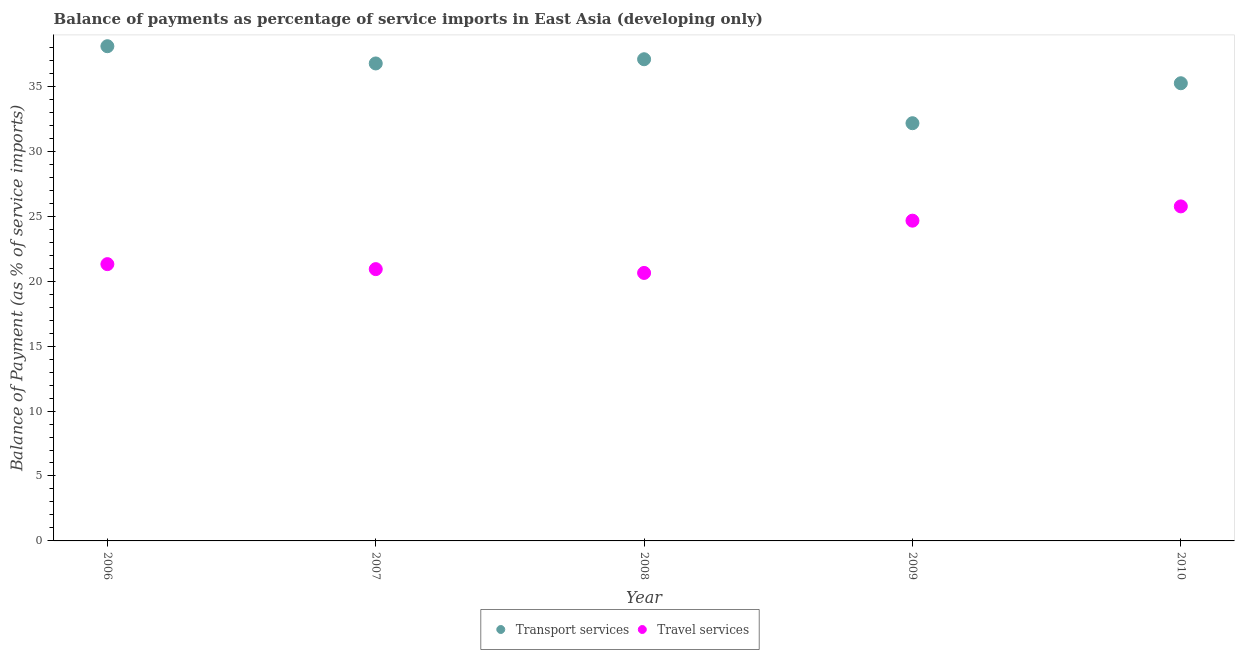How many different coloured dotlines are there?
Provide a short and direct response. 2. What is the balance of payments of travel services in 2010?
Your answer should be very brief. 25.76. Across all years, what is the maximum balance of payments of travel services?
Offer a terse response. 25.76. Across all years, what is the minimum balance of payments of transport services?
Make the answer very short. 32.16. In which year was the balance of payments of travel services maximum?
Offer a terse response. 2010. What is the total balance of payments of transport services in the graph?
Provide a short and direct response. 179.33. What is the difference between the balance of payments of travel services in 2008 and that in 2010?
Your answer should be compact. -5.12. What is the difference between the balance of payments of transport services in 2007 and the balance of payments of travel services in 2008?
Make the answer very short. 16.13. What is the average balance of payments of transport services per year?
Offer a terse response. 35.87. In the year 2008, what is the difference between the balance of payments of transport services and balance of payments of travel services?
Ensure brevity in your answer.  16.45. What is the ratio of the balance of payments of transport services in 2009 to that in 2010?
Your answer should be very brief. 0.91. Is the balance of payments of transport services in 2008 less than that in 2009?
Provide a succinct answer. No. Is the difference between the balance of payments of travel services in 2007 and 2010 greater than the difference between the balance of payments of transport services in 2007 and 2010?
Provide a succinct answer. No. What is the difference between the highest and the second highest balance of payments of transport services?
Keep it short and to the point. 1. What is the difference between the highest and the lowest balance of payments of travel services?
Ensure brevity in your answer.  5.12. Is the sum of the balance of payments of transport services in 2006 and 2009 greater than the maximum balance of payments of travel services across all years?
Keep it short and to the point. Yes. Is the balance of payments of travel services strictly greater than the balance of payments of transport services over the years?
Provide a succinct answer. No. How many dotlines are there?
Ensure brevity in your answer.  2. How many years are there in the graph?
Provide a short and direct response. 5. What is the difference between two consecutive major ticks on the Y-axis?
Offer a very short reply. 5. How many legend labels are there?
Keep it short and to the point. 2. How are the legend labels stacked?
Offer a terse response. Horizontal. What is the title of the graph?
Your response must be concise. Balance of payments as percentage of service imports in East Asia (developing only). What is the label or title of the Y-axis?
Offer a terse response. Balance of Payment (as % of service imports). What is the Balance of Payment (as % of service imports) in Transport services in 2006?
Ensure brevity in your answer.  38.09. What is the Balance of Payment (as % of service imports) in Travel services in 2006?
Offer a very short reply. 21.31. What is the Balance of Payment (as % of service imports) of Transport services in 2007?
Provide a succinct answer. 36.76. What is the Balance of Payment (as % of service imports) in Travel services in 2007?
Give a very brief answer. 20.93. What is the Balance of Payment (as % of service imports) of Transport services in 2008?
Your response must be concise. 37.09. What is the Balance of Payment (as % of service imports) in Travel services in 2008?
Provide a short and direct response. 20.63. What is the Balance of Payment (as % of service imports) of Transport services in 2009?
Ensure brevity in your answer.  32.16. What is the Balance of Payment (as % of service imports) of Travel services in 2009?
Ensure brevity in your answer.  24.66. What is the Balance of Payment (as % of service imports) of Transport services in 2010?
Keep it short and to the point. 35.24. What is the Balance of Payment (as % of service imports) of Travel services in 2010?
Offer a terse response. 25.76. Across all years, what is the maximum Balance of Payment (as % of service imports) in Transport services?
Give a very brief answer. 38.09. Across all years, what is the maximum Balance of Payment (as % of service imports) of Travel services?
Ensure brevity in your answer.  25.76. Across all years, what is the minimum Balance of Payment (as % of service imports) of Transport services?
Provide a succinct answer. 32.16. Across all years, what is the minimum Balance of Payment (as % of service imports) in Travel services?
Ensure brevity in your answer.  20.63. What is the total Balance of Payment (as % of service imports) of Transport services in the graph?
Provide a short and direct response. 179.33. What is the total Balance of Payment (as % of service imports) in Travel services in the graph?
Keep it short and to the point. 113.28. What is the difference between the Balance of Payment (as % of service imports) in Transport services in 2006 and that in 2007?
Your answer should be very brief. 1.33. What is the difference between the Balance of Payment (as % of service imports) in Travel services in 2006 and that in 2007?
Your answer should be compact. 0.38. What is the difference between the Balance of Payment (as % of service imports) in Transport services in 2006 and that in 2008?
Your answer should be very brief. 1. What is the difference between the Balance of Payment (as % of service imports) in Travel services in 2006 and that in 2008?
Offer a terse response. 0.68. What is the difference between the Balance of Payment (as % of service imports) of Transport services in 2006 and that in 2009?
Your answer should be compact. 5.93. What is the difference between the Balance of Payment (as % of service imports) of Travel services in 2006 and that in 2009?
Keep it short and to the point. -3.35. What is the difference between the Balance of Payment (as % of service imports) of Transport services in 2006 and that in 2010?
Your answer should be compact. 2.85. What is the difference between the Balance of Payment (as % of service imports) in Travel services in 2006 and that in 2010?
Ensure brevity in your answer.  -4.45. What is the difference between the Balance of Payment (as % of service imports) in Transport services in 2007 and that in 2008?
Make the answer very short. -0.32. What is the difference between the Balance of Payment (as % of service imports) in Travel services in 2007 and that in 2008?
Offer a very short reply. 0.29. What is the difference between the Balance of Payment (as % of service imports) of Transport services in 2007 and that in 2009?
Offer a very short reply. 4.6. What is the difference between the Balance of Payment (as % of service imports) of Travel services in 2007 and that in 2009?
Your answer should be compact. -3.73. What is the difference between the Balance of Payment (as % of service imports) of Transport services in 2007 and that in 2010?
Offer a terse response. 1.52. What is the difference between the Balance of Payment (as % of service imports) of Travel services in 2007 and that in 2010?
Offer a very short reply. -4.83. What is the difference between the Balance of Payment (as % of service imports) in Transport services in 2008 and that in 2009?
Provide a short and direct response. 4.93. What is the difference between the Balance of Payment (as % of service imports) of Travel services in 2008 and that in 2009?
Make the answer very short. -4.02. What is the difference between the Balance of Payment (as % of service imports) in Transport services in 2008 and that in 2010?
Make the answer very short. 1.85. What is the difference between the Balance of Payment (as % of service imports) of Travel services in 2008 and that in 2010?
Your answer should be very brief. -5.12. What is the difference between the Balance of Payment (as % of service imports) in Transport services in 2009 and that in 2010?
Give a very brief answer. -3.08. What is the difference between the Balance of Payment (as % of service imports) in Travel services in 2009 and that in 2010?
Provide a succinct answer. -1.1. What is the difference between the Balance of Payment (as % of service imports) of Transport services in 2006 and the Balance of Payment (as % of service imports) of Travel services in 2007?
Offer a terse response. 17.16. What is the difference between the Balance of Payment (as % of service imports) of Transport services in 2006 and the Balance of Payment (as % of service imports) of Travel services in 2008?
Offer a very short reply. 17.46. What is the difference between the Balance of Payment (as % of service imports) of Transport services in 2006 and the Balance of Payment (as % of service imports) of Travel services in 2009?
Offer a terse response. 13.43. What is the difference between the Balance of Payment (as % of service imports) of Transport services in 2006 and the Balance of Payment (as % of service imports) of Travel services in 2010?
Offer a very short reply. 12.33. What is the difference between the Balance of Payment (as % of service imports) in Transport services in 2007 and the Balance of Payment (as % of service imports) in Travel services in 2008?
Offer a terse response. 16.13. What is the difference between the Balance of Payment (as % of service imports) of Transport services in 2007 and the Balance of Payment (as % of service imports) of Travel services in 2009?
Offer a very short reply. 12.1. What is the difference between the Balance of Payment (as % of service imports) in Transport services in 2007 and the Balance of Payment (as % of service imports) in Travel services in 2010?
Your answer should be very brief. 11.01. What is the difference between the Balance of Payment (as % of service imports) in Transport services in 2008 and the Balance of Payment (as % of service imports) in Travel services in 2009?
Offer a very short reply. 12.43. What is the difference between the Balance of Payment (as % of service imports) of Transport services in 2008 and the Balance of Payment (as % of service imports) of Travel services in 2010?
Give a very brief answer. 11.33. What is the difference between the Balance of Payment (as % of service imports) in Transport services in 2009 and the Balance of Payment (as % of service imports) in Travel services in 2010?
Give a very brief answer. 6.4. What is the average Balance of Payment (as % of service imports) in Transport services per year?
Your answer should be compact. 35.87. What is the average Balance of Payment (as % of service imports) of Travel services per year?
Offer a very short reply. 22.66. In the year 2006, what is the difference between the Balance of Payment (as % of service imports) in Transport services and Balance of Payment (as % of service imports) in Travel services?
Ensure brevity in your answer.  16.78. In the year 2007, what is the difference between the Balance of Payment (as % of service imports) in Transport services and Balance of Payment (as % of service imports) in Travel services?
Offer a terse response. 15.84. In the year 2008, what is the difference between the Balance of Payment (as % of service imports) of Transport services and Balance of Payment (as % of service imports) of Travel services?
Give a very brief answer. 16.45. In the year 2009, what is the difference between the Balance of Payment (as % of service imports) in Transport services and Balance of Payment (as % of service imports) in Travel services?
Your response must be concise. 7.5. In the year 2010, what is the difference between the Balance of Payment (as % of service imports) in Transport services and Balance of Payment (as % of service imports) in Travel services?
Keep it short and to the point. 9.48. What is the ratio of the Balance of Payment (as % of service imports) in Transport services in 2006 to that in 2007?
Keep it short and to the point. 1.04. What is the ratio of the Balance of Payment (as % of service imports) of Travel services in 2006 to that in 2007?
Your answer should be compact. 1.02. What is the ratio of the Balance of Payment (as % of service imports) in Transport services in 2006 to that in 2008?
Offer a very short reply. 1.03. What is the ratio of the Balance of Payment (as % of service imports) of Travel services in 2006 to that in 2008?
Ensure brevity in your answer.  1.03. What is the ratio of the Balance of Payment (as % of service imports) in Transport services in 2006 to that in 2009?
Ensure brevity in your answer.  1.18. What is the ratio of the Balance of Payment (as % of service imports) in Travel services in 2006 to that in 2009?
Give a very brief answer. 0.86. What is the ratio of the Balance of Payment (as % of service imports) in Transport services in 2006 to that in 2010?
Give a very brief answer. 1.08. What is the ratio of the Balance of Payment (as % of service imports) in Travel services in 2006 to that in 2010?
Your answer should be very brief. 0.83. What is the ratio of the Balance of Payment (as % of service imports) in Travel services in 2007 to that in 2008?
Provide a short and direct response. 1.01. What is the ratio of the Balance of Payment (as % of service imports) in Transport services in 2007 to that in 2009?
Ensure brevity in your answer.  1.14. What is the ratio of the Balance of Payment (as % of service imports) of Travel services in 2007 to that in 2009?
Offer a terse response. 0.85. What is the ratio of the Balance of Payment (as % of service imports) in Transport services in 2007 to that in 2010?
Your answer should be very brief. 1.04. What is the ratio of the Balance of Payment (as % of service imports) in Travel services in 2007 to that in 2010?
Provide a succinct answer. 0.81. What is the ratio of the Balance of Payment (as % of service imports) in Transport services in 2008 to that in 2009?
Provide a succinct answer. 1.15. What is the ratio of the Balance of Payment (as % of service imports) of Travel services in 2008 to that in 2009?
Your answer should be very brief. 0.84. What is the ratio of the Balance of Payment (as % of service imports) in Transport services in 2008 to that in 2010?
Your response must be concise. 1.05. What is the ratio of the Balance of Payment (as % of service imports) of Travel services in 2008 to that in 2010?
Provide a short and direct response. 0.8. What is the ratio of the Balance of Payment (as % of service imports) of Transport services in 2009 to that in 2010?
Provide a succinct answer. 0.91. What is the ratio of the Balance of Payment (as % of service imports) of Travel services in 2009 to that in 2010?
Offer a very short reply. 0.96. What is the difference between the highest and the second highest Balance of Payment (as % of service imports) of Travel services?
Offer a very short reply. 1.1. What is the difference between the highest and the lowest Balance of Payment (as % of service imports) in Transport services?
Give a very brief answer. 5.93. What is the difference between the highest and the lowest Balance of Payment (as % of service imports) of Travel services?
Give a very brief answer. 5.12. 